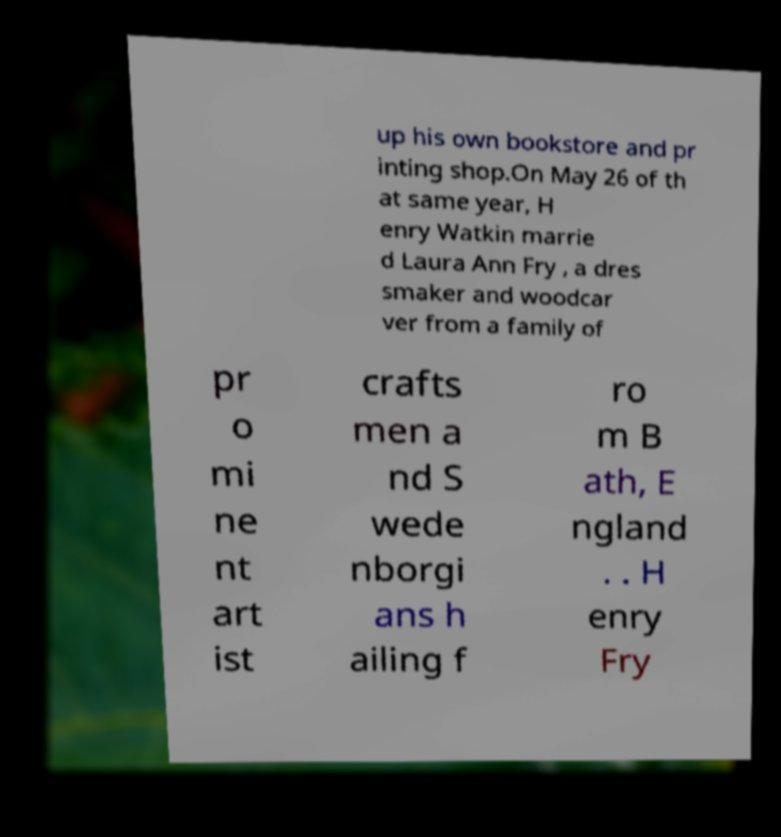I need the written content from this picture converted into text. Can you do that? up his own bookstore and pr inting shop.On May 26 of th at same year, H enry Watkin marrie d Laura Ann Fry , a dres smaker and woodcar ver from a family of pr o mi ne nt art ist crafts men a nd S wede nborgi ans h ailing f ro m B ath, E ngland . . H enry Fry 